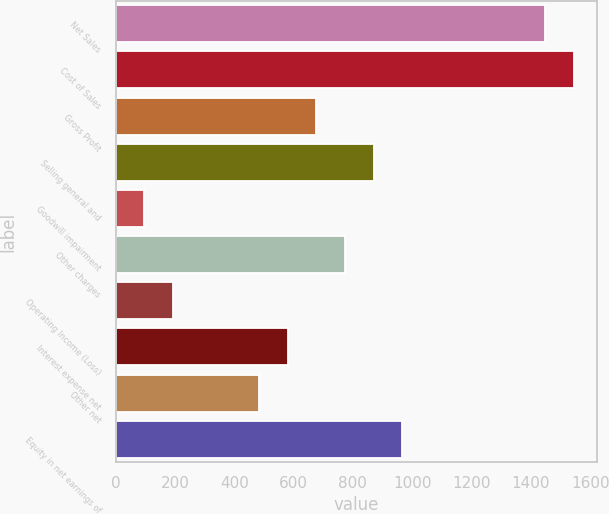Convert chart to OTSL. <chart><loc_0><loc_0><loc_500><loc_500><bar_chart><fcel>Net Sales<fcel>Cost of Sales<fcel>Gross Profit<fcel>Selling general and<fcel>Goodwill impairment<fcel>Other charges<fcel>Operating Income (Loss)<fcel>Interest expense net<fcel>Other net<fcel>Equity in net earnings of<nl><fcel>1448.87<fcel>1545.44<fcel>676.31<fcel>869.45<fcel>96.89<fcel>772.88<fcel>193.46<fcel>579.74<fcel>483.17<fcel>966.02<nl></chart> 